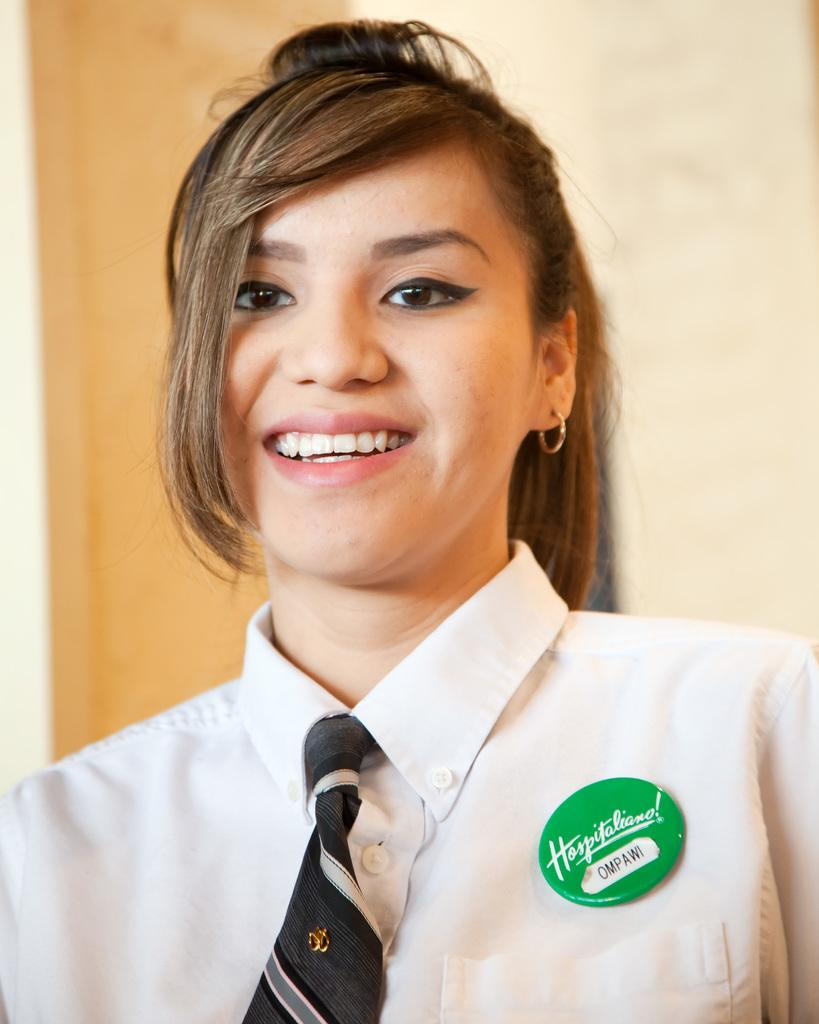Provide a one-sentence caption for the provided image. A woman wearing a name tag that says Ompawi. 